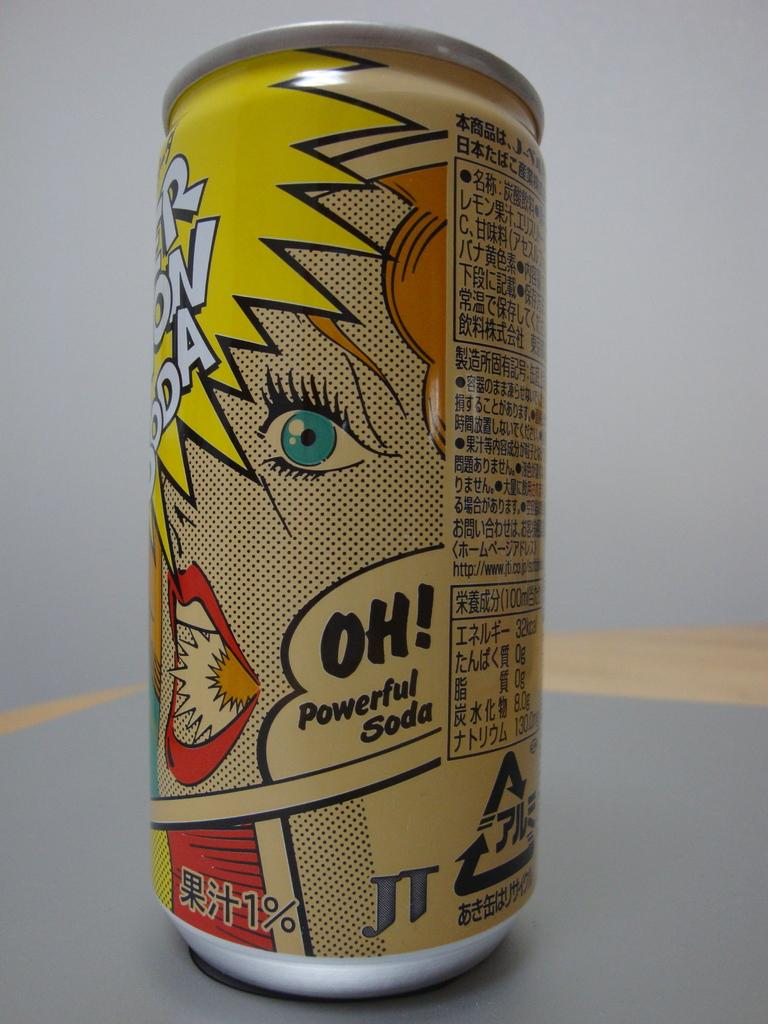<image>
Describe the image concisely. A can that has Oh Powerful Soda printed on it. 